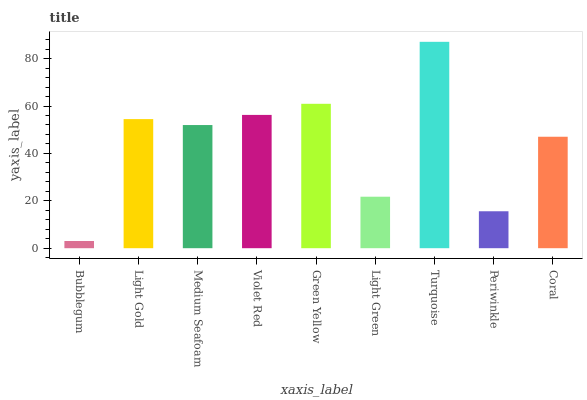Is Bubblegum the minimum?
Answer yes or no. Yes. Is Turquoise the maximum?
Answer yes or no. Yes. Is Light Gold the minimum?
Answer yes or no. No. Is Light Gold the maximum?
Answer yes or no. No. Is Light Gold greater than Bubblegum?
Answer yes or no. Yes. Is Bubblegum less than Light Gold?
Answer yes or no. Yes. Is Bubblegum greater than Light Gold?
Answer yes or no. No. Is Light Gold less than Bubblegum?
Answer yes or no. No. Is Medium Seafoam the high median?
Answer yes or no. Yes. Is Medium Seafoam the low median?
Answer yes or no. Yes. Is Light Gold the high median?
Answer yes or no. No. Is Violet Red the low median?
Answer yes or no. No. 